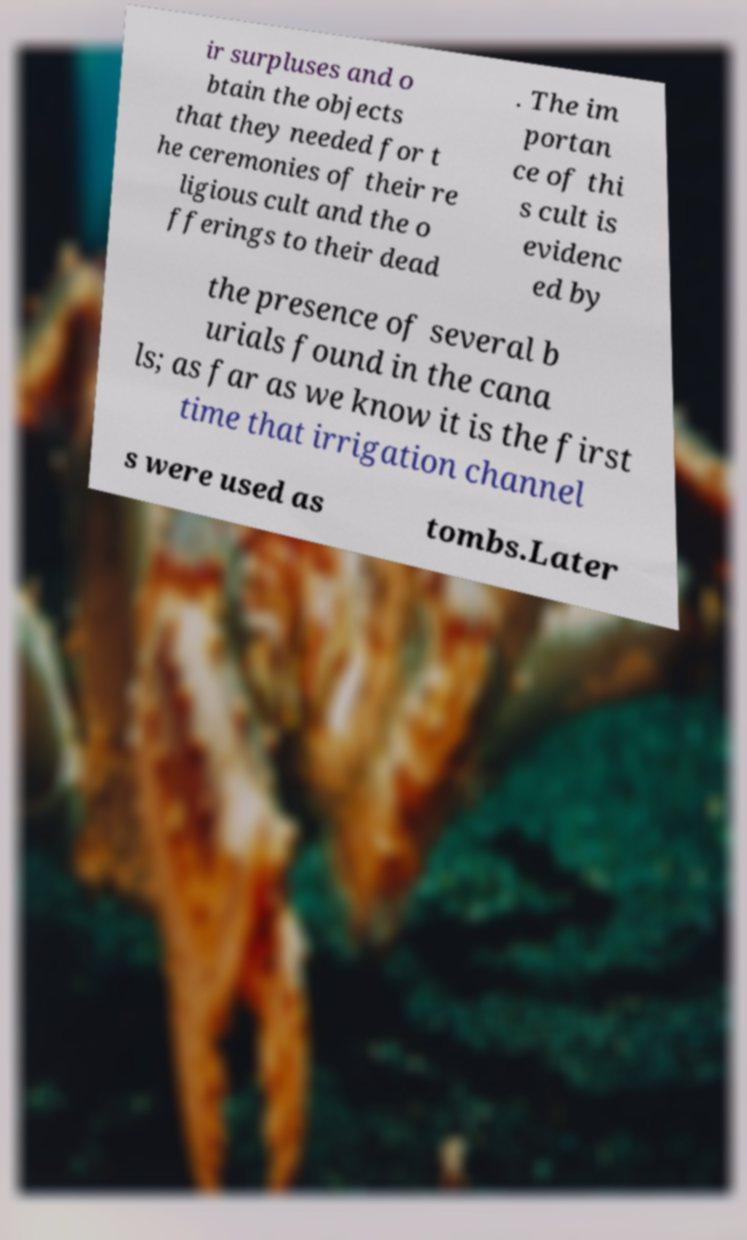Please read and relay the text visible in this image. What does it say? ir surpluses and o btain the objects that they needed for t he ceremonies of their re ligious cult and the o fferings to their dead . The im portan ce of thi s cult is evidenc ed by the presence of several b urials found in the cana ls; as far as we know it is the first time that irrigation channel s were used as tombs.Later 